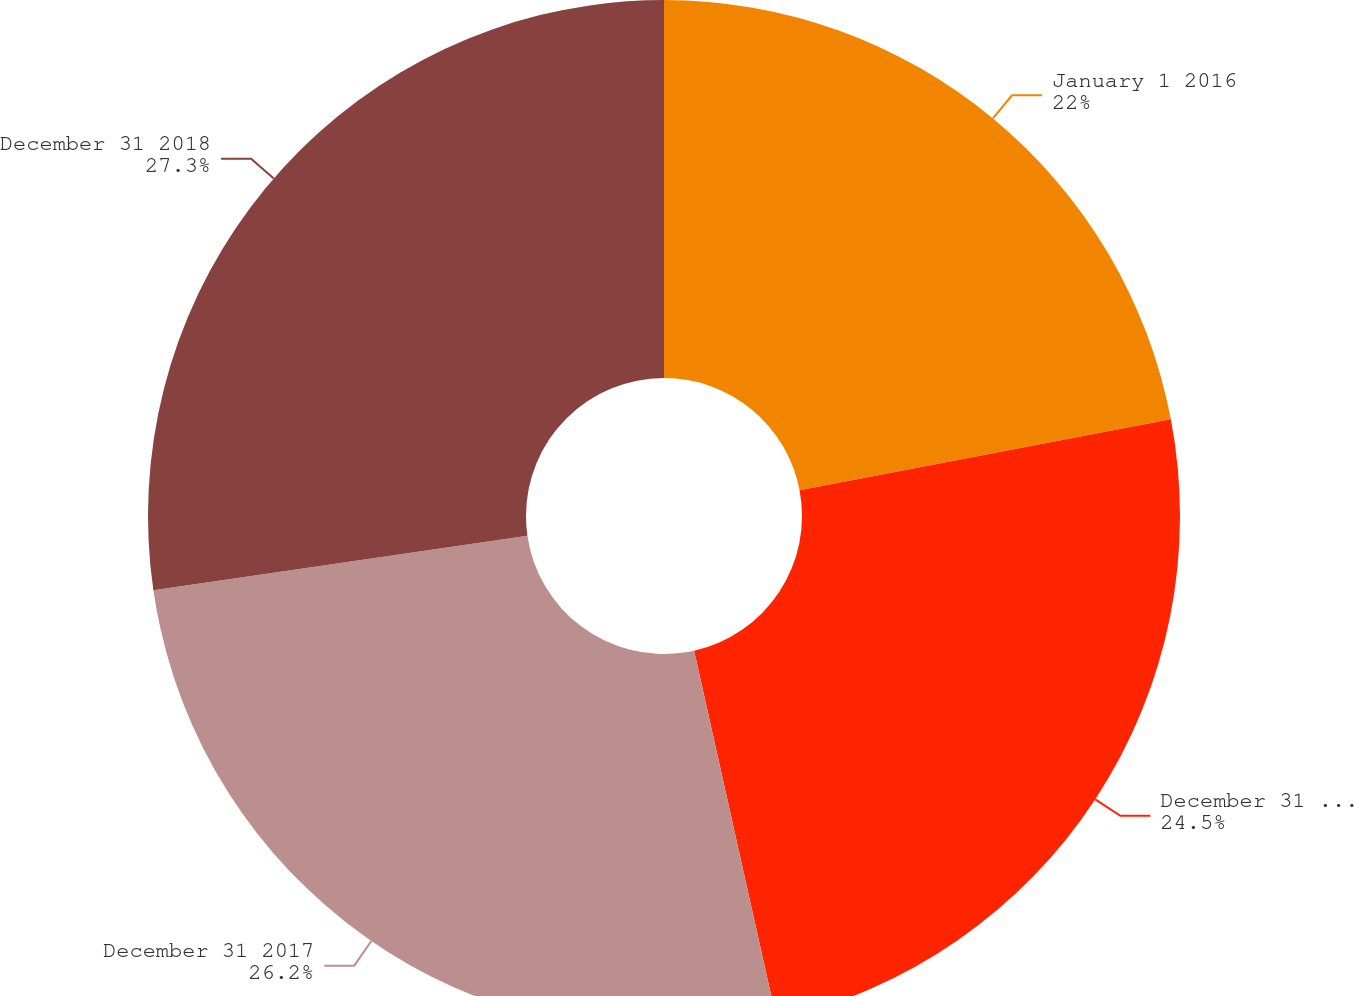Convert chart. <chart><loc_0><loc_0><loc_500><loc_500><pie_chart><fcel>January 1 2016<fcel>December 31 2016<fcel>December 31 2017<fcel>December 31 2018<nl><fcel>22.0%<fcel>24.5%<fcel>26.2%<fcel>27.3%<nl></chart> 